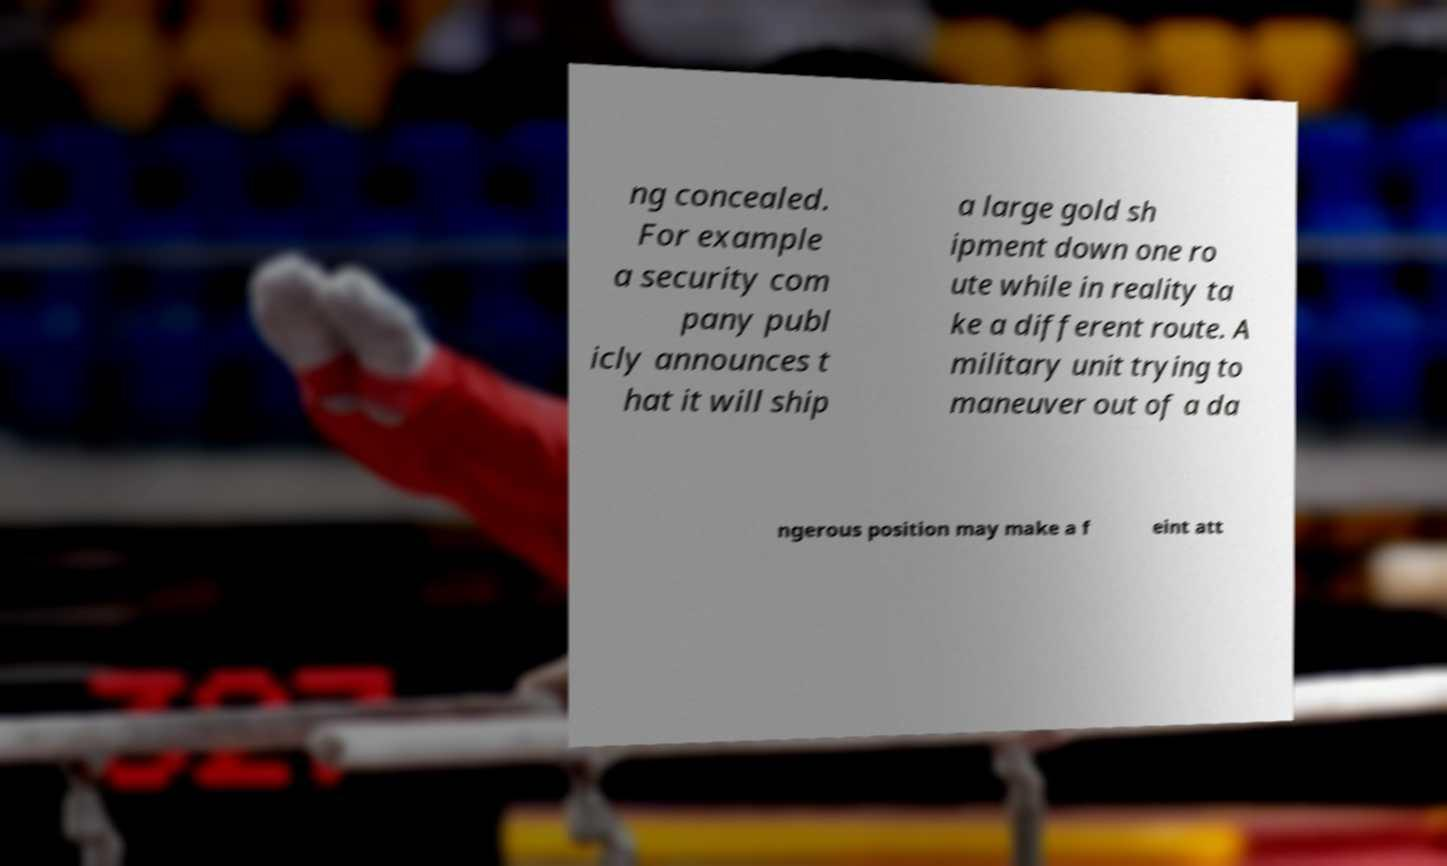Could you extract and type out the text from this image? ng concealed. For example a security com pany publ icly announces t hat it will ship a large gold sh ipment down one ro ute while in reality ta ke a different route. A military unit trying to maneuver out of a da ngerous position may make a f eint att 